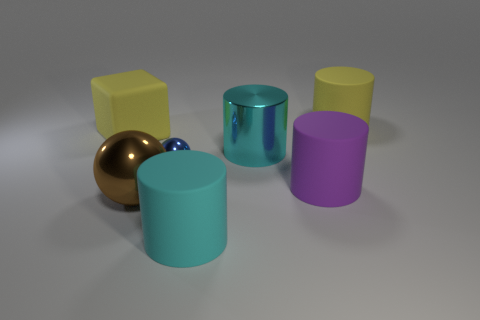There is a yellow matte thing that is on the left side of the big ball; is it the same shape as the blue thing?
Ensure brevity in your answer.  No. How many other yellow rubber cubes are the same size as the matte block?
Ensure brevity in your answer.  0. What is the shape of the large thing that is the same color as the big metal cylinder?
Ensure brevity in your answer.  Cylinder. Are there any cyan cylinders that are behind the large cyan object that is in front of the blue thing?
Keep it short and to the point. Yes. What number of things are matte things that are in front of the yellow matte cylinder or tiny blue shiny spheres?
Provide a succinct answer. 4. What number of big green matte blocks are there?
Offer a very short reply. 0. There is a big object that is made of the same material as the brown ball; what shape is it?
Your answer should be very brief. Cylinder. There is a metal sphere on the right side of the shiny sphere on the left side of the tiny sphere; how big is it?
Your answer should be very brief. Small. What number of objects are either big metal things behind the large purple matte cylinder or large rubber objects on the right side of the cyan rubber cylinder?
Give a very brief answer. 3. Are there fewer yellow cylinders than large cyan matte spheres?
Provide a succinct answer. No. 